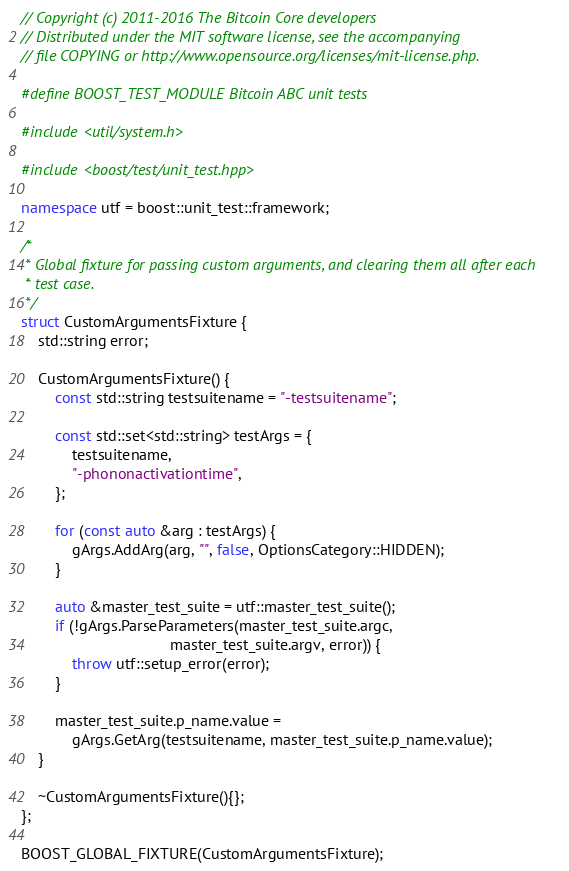Convert code to text. <code><loc_0><loc_0><loc_500><loc_500><_C++_>// Copyright (c) 2011-2016 The Bitcoin Core developers
// Distributed under the MIT software license, see the accompanying
// file COPYING or http://www.opensource.org/licenses/mit-license.php.

#define BOOST_TEST_MODULE Bitcoin ABC unit tests

#include <util/system.h>

#include <boost/test/unit_test.hpp>

namespace utf = boost::unit_test::framework;

/*
 * Global fixture for passing custom arguments, and clearing them all after each
 * test case.
 */
struct CustomArgumentsFixture {
    std::string error;

    CustomArgumentsFixture() {
        const std::string testsuitename = "-testsuitename";

        const std::set<std::string> testArgs = {
            testsuitename,
            "-phononactivationtime",
        };

        for (const auto &arg : testArgs) {
            gArgs.AddArg(arg, "", false, OptionsCategory::HIDDEN);
        }

        auto &master_test_suite = utf::master_test_suite();
        if (!gArgs.ParseParameters(master_test_suite.argc,
                                   master_test_suite.argv, error)) {
            throw utf::setup_error(error);
        }

        master_test_suite.p_name.value =
            gArgs.GetArg(testsuitename, master_test_suite.p_name.value);
    }

    ~CustomArgumentsFixture(){};
};

BOOST_GLOBAL_FIXTURE(CustomArgumentsFixture);
</code> 